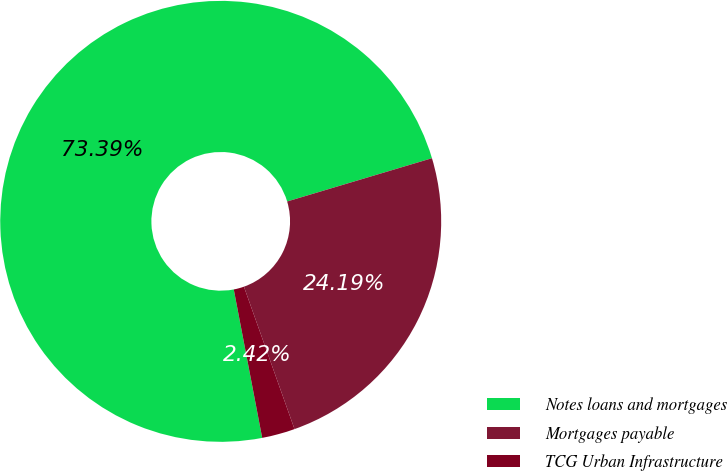Convert chart to OTSL. <chart><loc_0><loc_0><loc_500><loc_500><pie_chart><fcel>Notes loans and mortgages<fcel>Mortgages payable<fcel>TCG Urban Infrastructure<nl><fcel>73.39%<fcel>24.19%<fcel>2.42%<nl></chart> 